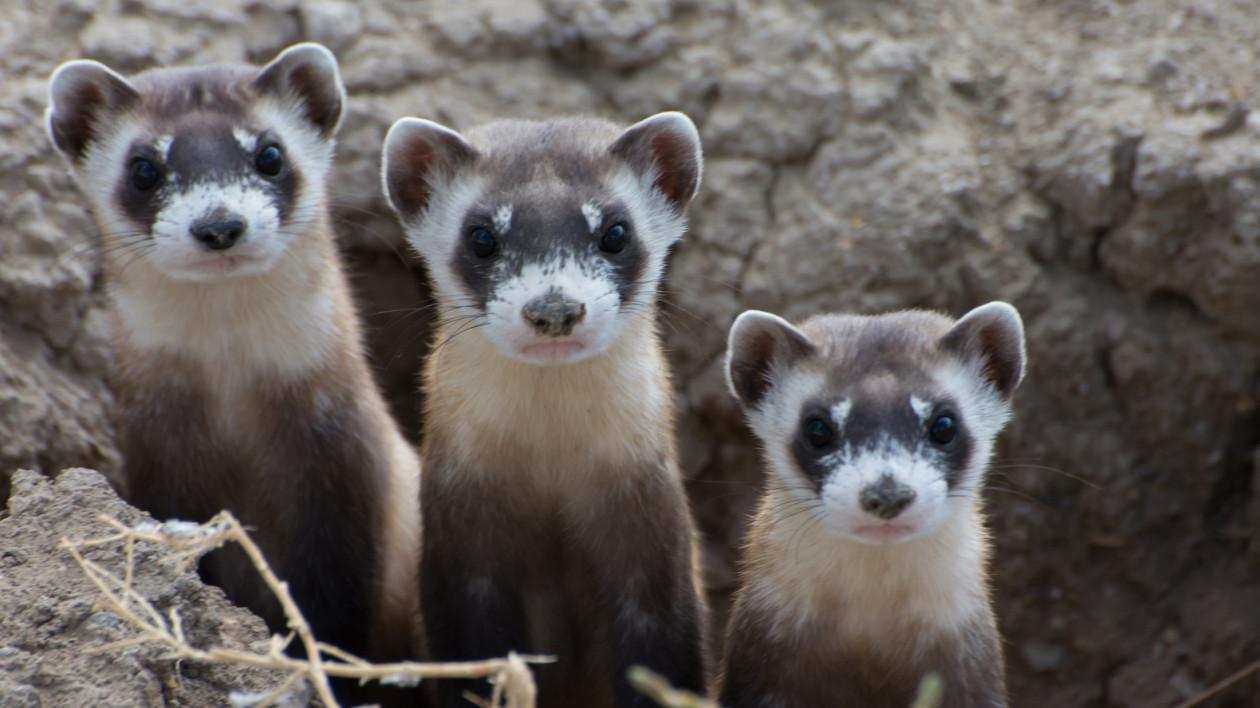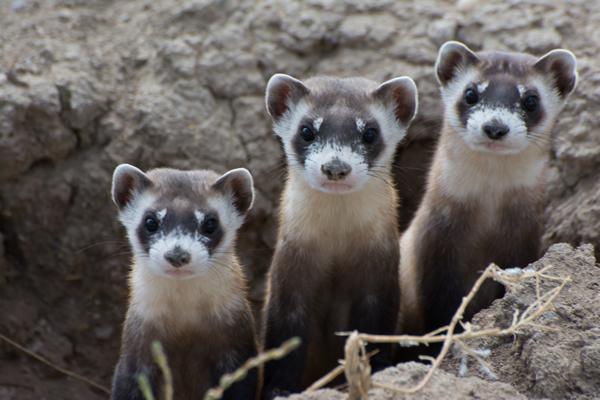The first image is the image on the left, the second image is the image on the right. Assess this claim about the two images: "Exactly one image shows exactly three ferrets poking their heads up above the ground.". Correct or not? Answer yes or no. No. The first image is the image on the left, the second image is the image on the right. Given the left and right images, does the statement "There are more than five prairie dogs poking up from the ground." hold true? Answer yes or no. Yes. 